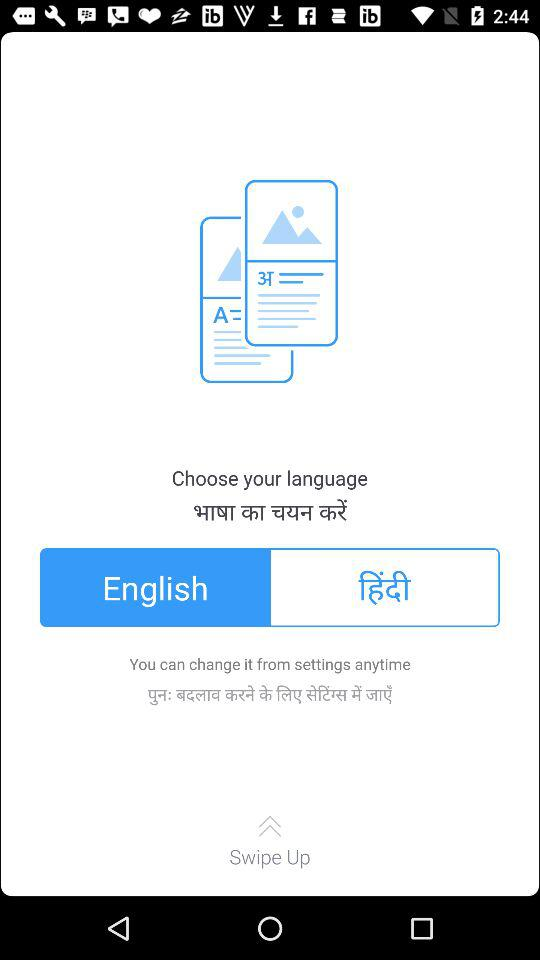How many languages are available to choose from?
Answer the question using a single word or phrase. 2 